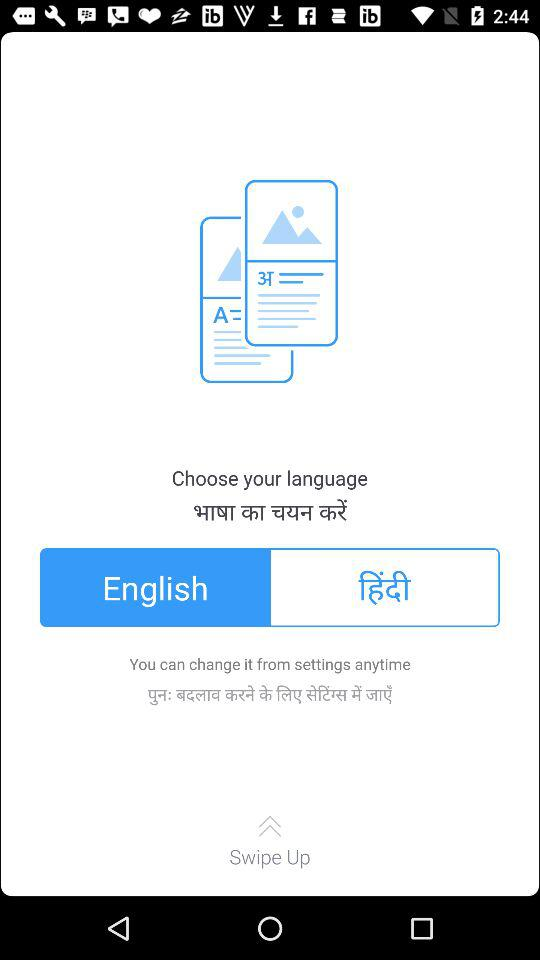How many languages are available to choose from?
Answer the question using a single word or phrase. 2 